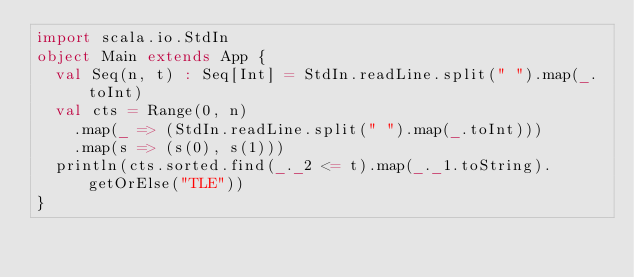<code> <loc_0><loc_0><loc_500><loc_500><_Scala_>import scala.io.StdIn
object Main extends App {
  val Seq(n, t) : Seq[Int] = StdIn.readLine.split(" ").map(_.toInt)
  val cts = Range(0, n)
    .map(_ => (StdIn.readLine.split(" ").map(_.toInt)))
    .map(s => (s(0), s(1)))
  println(cts.sorted.find(_._2 <= t).map(_._1.toString).getOrElse("TLE"))
}
</code> 